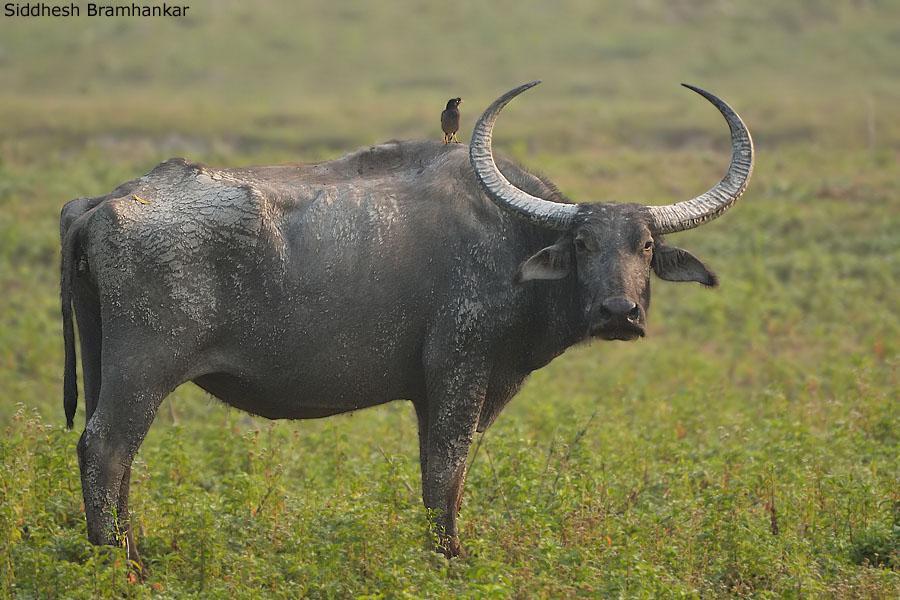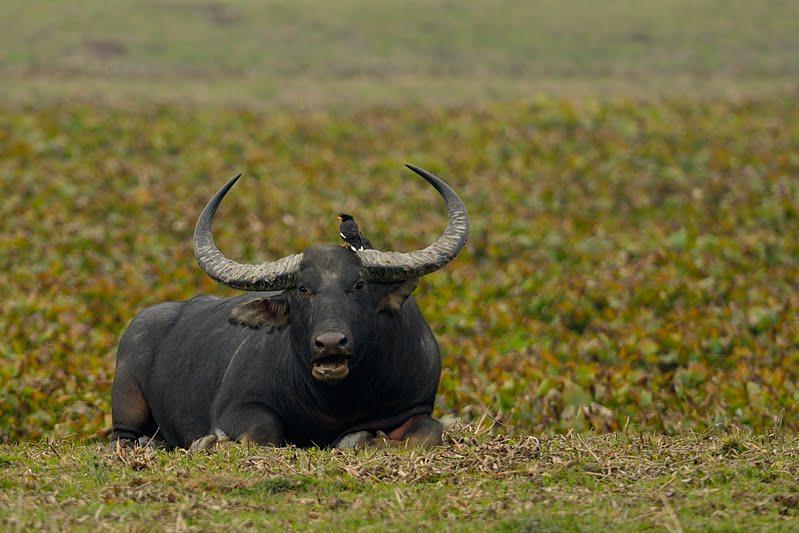The first image is the image on the left, the second image is the image on the right. Analyze the images presented: Is the assertion "The right image contains no more than one water buffalo." valid? Answer yes or no. Yes. The first image is the image on the left, the second image is the image on the right. Evaluate the accuracy of this statement regarding the images: "The righthand image shows exactly one water buffalo, which faces the camera.". Is it true? Answer yes or no. Yes. 